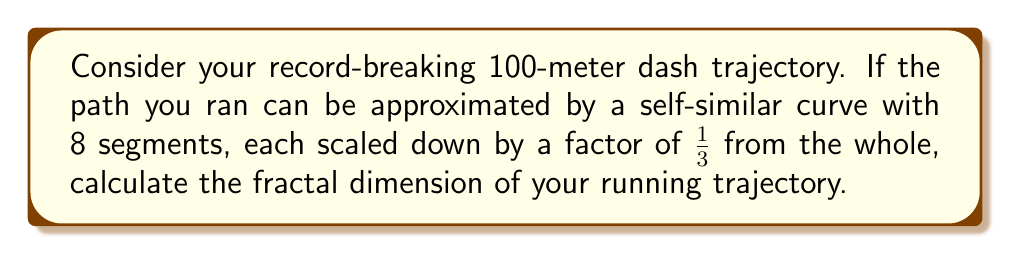Could you help me with this problem? To calculate the fractal dimension of the athlete's running trajectory, we'll use the box-counting dimension formula, which is a method for determining the fractal dimension of a self-similar set.

The formula for the fractal dimension (D) is:

$$ D = \frac{\log N}{\log(1/r)} $$

Where:
- N is the number of self-similar pieces
- r is the scaling factor

Given:
- N = 8 (8 segments)
- r = 1/3 (each segment is scaled down by a factor of 1/3)

Step 1: Substitute the values into the formula:

$$ D = \frac{\log 8}{\log(1/(1/3))} = \frac{\log 8}{\log 3} $$

Step 2: Calculate the logarithms:

$$ D = \frac{\log 8}{\log 3} \approx \frac{2.0794}{1.0986} $$

Step 3: Perform the division:

$$ D \approx 1.8928 $$

The fractal dimension of the athlete's running trajectory is approximately 1.8928, which is between 1 (a straight line) and 2 (a plane), indicating a complex, fractal-like path.
Answer: $D \approx 1.8928$ 